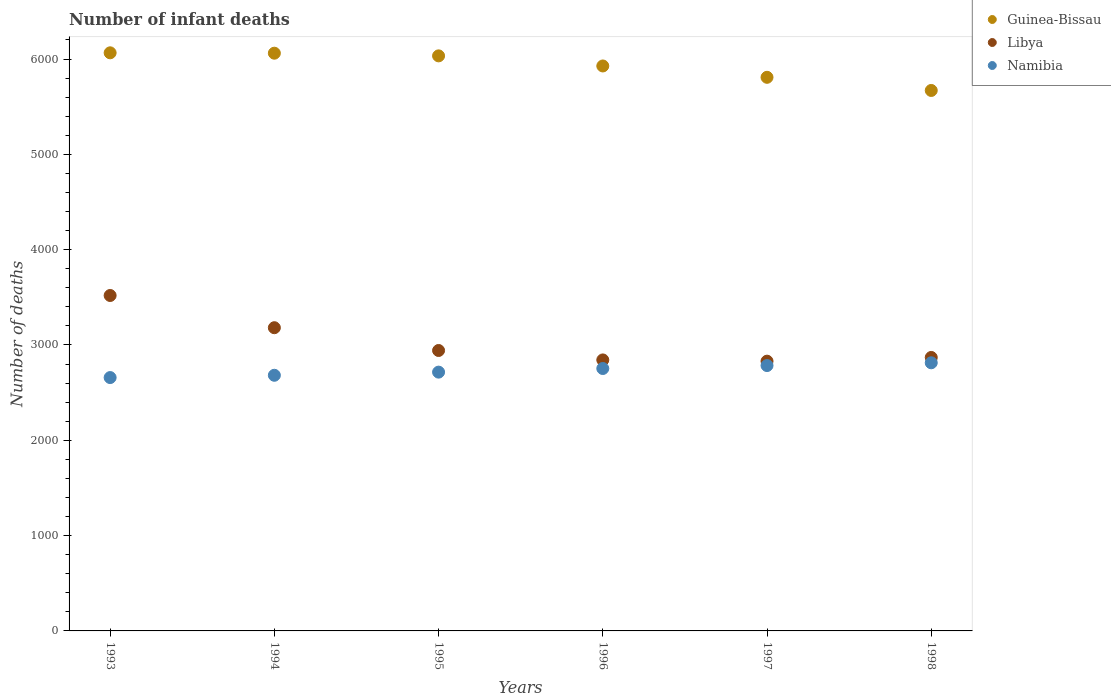How many different coloured dotlines are there?
Offer a terse response. 3. What is the number of infant deaths in Libya in 1994?
Provide a short and direct response. 3181. Across all years, what is the maximum number of infant deaths in Libya?
Your answer should be compact. 3519. Across all years, what is the minimum number of infant deaths in Guinea-Bissau?
Keep it short and to the point. 5670. In which year was the number of infant deaths in Libya maximum?
Your answer should be very brief. 1993. In which year was the number of infant deaths in Guinea-Bissau minimum?
Offer a terse response. 1998. What is the total number of infant deaths in Guinea-Bissau in the graph?
Give a very brief answer. 3.56e+04. What is the difference between the number of infant deaths in Libya in 1997 and that in 1998?
Provide a succinct answer. -39. What is the difference between the number of infant deaths in Libya in 1993 and the number of infant deaths in Namibia in 1998?
Keep it short and to the point. 706. What is the average number of infant deaths in Namibia per year?
Give a very brief answer. 2734.17. In the year 1997, what is the difference between the number of infant deaths in Guinea-Bissau and number of infant deaths in Libya?
Your answer should be compact. 2978. What is the ratio of the number of infant deaths in Guinea-Bissau in 1994 to that in 1996?
Provide a succinct answer. 1.02. Is the number of infant deaths in Libya in 1994 less than that in 1995?
Provide a short and direct response. No. Is the difference between the number of infant deaths in Guinea-Bissau in 1993 and 1997 greater than the difference between the number of infant deaths in Libya in 1993 and 1997?
Provide a short and direct response. No. What is the difference between the highest and the second highest number of infant deaths in Namibia?
Provide a succinct answer. 29. What is the difference between the highest and the lowest number of infant deaths in Namibia?
Ensure brevity in your answer.  155. Is the number of infant deaths in Namibia strictly less than the number of infant deaths in Libya over the years?
Make the answer very short. Yes. How many years are there in the graph?
Your response must be concise. 6. What is the difference between two consecutive major ticks on the Y-axis?
Provide a short and direct response. 1000. Where does the legend appear in the graph?
Your answer should be very brief. Top right. What is the title of the graph?
Offer a terse response. Number of infant deaths. Does "Thailand" appear as one of the legend labels in the graph?
Offer a very short reply. No. What is the label or title of the Y-axis?
Your answer should be very brief. Number of deaths. What is the Number of deaths of Guinea-Bissau in 1993?
Provide a short and direct response. 6065. What is the Number of deaths of Libya in 1993?
Ensure brevity in your answer.  3519. What is the Number of deaths in Namibia in 1993?
Offer a very short reply. 2658. What is the Number of deaths of Guinea-Bissau in 1994?
Keep it short and to the point. 6061. What is the Number of deaths in Libya in 1994?
Offer a very short reply. 3181. What is the Number of deaths in Namibia in 1994?
Provide a short and direct response. 2682. What is the Number of deaths of Guinea-Bissau in 1995?
Your answer should be very brief. 6033. What is the Number of deaths of Libya in 1995?
Make the answer very short. 2942. What is the Number of deaths of Namibia in 1995?
Offer a very short reply. 2715. What is the Number of deaths in Guinea-Bissau in 1996?
Keep it short and to the point. 5927. What is the Number of deaths in Libya in 1996?
Give a very brief answer. 2843. What is the Number of deaths in Namibia in 1996?
Keep it short and to the point. 2753. What is the Number of deaths of Guinea-Bissau in 1997?
Provide a short and direct response. 5808. What is the Number of deaths in Libya in 1997?
Provide a succinct answer. 2830. What is the Number of deaths of Namibia in 1997?
Make the answer very short. 2784. What is the Number of deaths of Guinea-Bissau in 1998?
Provide a short and direct response. 5670. What is the Number of deaths of Libya in 1998?
Offer a very short reply. 2869. What is the Number of deaths in Namibia in 1998?
Give a very brief answer. 2813. Across all years, what is the maximum Number of deaths of Guinea-Bissau?
Offer a terse response. 6065. Across all years, what is the maximum Number of deaths of Libya?
Your answer should be compact. 3519. Across all years, what is the maximum Number of deaths in Namibia?
Make the answer very short. 2813. Across all years, what is the minimum Number of deaths of Guinea-Bissau?
Give a very brief answer. 5670. Across all years, what is the minimum Number of deaths in Libya?
Provide a short and direct response. 2830. Across all years, what is the minimum Number of deaths of Namibia?
Your answer should be very brief. 2658. What is the total Number of deaths in Guinea-Bissau in the graph?
Offer a terse response. 3.56e+04. What is the total Number of deaths in Libya in the graph?
Your response must be concise. 1.82e+04. What is the total Number of deaths of Namibia in the graph?
Provide a succinct answer. 1.64e+04. What is the difference between the Number of deaths in Guinea-Bissau in 1993 and that in 1994?
Provide a short and direct response. 4. What is the difference between the Number of deaths of Libya in 1993 and that in 1994?
Give a very brief answer. 338. What is the difference between the Number of deaths in Libya in 1993 and that in 1995?
Ensure brevity in your answer.  577. What is the difference between the Number of deaths of Namibia in 1993 and that in 1995?
Your response must be concise. -57. What is the difference between the Number of deaths of Guinea-Bissau in 1993 and that in 1996?
Give a very brief answer. 138. What is the difference between the Number of deaths in Libya in 1993 and that in 1996?
Your response must be concise. 676. What is the difference between the Number of deaths of Namibia in 1993 and that in 1996?
Your answer should be compact. -95. What is the difference between the Number of deaths in Guinea-Bissau in 1993 and that in 1997?
Your answer should be very brief. 257. What is the difference between the Number of deaths of Libya in 1993 and that in 1997?
Give a very brief answer. 689. What is the difference between the Number of deaths of Namibia in 1993 and that in 1997?
Provide a succinct answer. -126. What is the difference between the Number of deaths in Guinea-Bissau in 1993 and that in 1998?
Offer a terse response. 395. What is the difference between the Number of deaths in Libya in 1993 and that in 1998?
Offer a very short reply. 650. What is the difference between the Number of deaths in Namibia in 1993 and that in 1998?
Keep it short and to the point. -155. What is the difference between the Number of deaths of Libya in 1994 and that in 1995?
Ensure brevity in your answer.  239. What is the difference between the Number of deaths in Namibia in 1994 and that in 1995?
Your answer should be very brief. -33. What is the difference between the Number of deaths of Guinea-Bissau in 1994 and that in 1996?
Your answer should be very brief. 134. What is the difference between the Number of deaths of Libya in 1994 and that in 1996?
Keep it short and to the point. 338. What is the difference between the Number of deaths of Namibia in 1994 and that in 1996?
Provide a short and direct response. -71. What is the difference between the Number of deaths of Guinea-Bissau in 1994 and that in 1997?
Your answer should be very brief. 253. What is the difference between the Number of deaths of Libya in 1994 and that in 1997?
Your answer should be compact. 351. What is the difference between the Number of deaths in Namibia in 1994 and that in 1997?
Provide a short and direct response. -102. What is the difference between the Number of deaths in Guinea-Bissau in 1994 and that in 1998?
Offer a very short reply. 391. What is the difference between the Number of deaths of Libya in 1994 and that in 1998?
Give a very brief answer. 312. What is the difference between the Number of deaths of Namibia in 1994 and that in 1998?
Keep it short and to the point. -131. What is the difference between the Number of deaths in Guinea-Bissau in 1995 and that in 1996?
Ensure brevity in your answer.  106. What is the difference between the Number of deaths in Namibia in 1995 and that in 1996?
Keep it short and to the point. -38. What is the difference between the Number of deaths of Guinea-Bissau in 1995 and that in 1997?
Offer a very short reply. 225. What is the difference between the Number of deaths of Libya in 1995 and that in 1997?
Provide a succinct answer. 112. What is the difference between the Number of deaths in Namibia in 1995 and that in 1997?
Your response must be concise. -69. What is the difference between the Number of deaths in Guinea-Bissau in 1995 and that in 1998?
Make the answer very short. 363. What is the difference between the Number of deaths of Namibia in 1995 and that in 1998?
Make the answer very short. -98. What is the difference between the Number of deaths in Guinea-Bissau in 1996 and that in 1997?
Ensure brevity in your answer.  119. What is the difference between the Number of deaths of Namibia in 1996 and that in 1997?
Keep it short and to the point. -31. What is the difference between the Number of deaths in Guinea-Bissau in 1996 and that in 1998?
Provide a short and direct response. 257. What is the difference between the Number of deaths in Namibia in 1996 and that in 1998?
Provide a short and direct response. -60. What is the difference between the Number of deaths of Guinea-Bissau in 1997 and that in 1998?
Give a very brief answer. 138. What is the difference between the Number of deaths in Libya in 1997 and that in 1998?
Ensure brevity in your answer.  -39. What is the difference between the Number of deaths of Guinea-Bissau in 1993 and the Number of deaths of Libya in 1994?
Ensure brevity in your answer.  2884. What is the difference between the Number of deaths of Guinea-Bissau in 1993 and the Number of deaths of Namibia in 1994?
Your response must be concise. 3383. What is the difference between the Number of deaths of Libya in 1993 and the Number of deaths of Namibia in 1994?
Your answer should be compact. 837. What is the difference between the Number of deaths of Guinea-Bissau in 1993 and the Number of deaths of Libya in 1995?
Make the answer very short. 3123. What is the difference between the Number of deaths in Guinea-Bissau in 1993 and the Number of deaths in Namibia in 1995?
Provide a short and direct response. 3350. What is the difference between the Number of deaths of Libya in 1993 and the Number of deaths of Namibia in 1995?
Your answer should be compact. 804. What is the difference between the Number of deaths of Guinea-Bissau in 1993 and the Number of deaths of Libya in 1996?
Offer a very short reply. 3222. What is the difference between the Number of deaths in Guinea-Bissau in 1993 and the Number of deaths in Namibia in 1996?
Offer a terse response. 3312. What is the difference between the Number of deaths of Libya in 1993 and the Number of deaths of Namibia in 1996?
Give a very brief answer. 766. What is the difference between the Number of deaths in Guinea-Bissau in 1993 and the Number of deaths in Libya in 1997?
Your response must be concise. 3235. What is the difference between the Number of deaths of Guinea-Bissau in 1993 and the Number of deaths of Namibia in 1997?
Ensure brevity in your answer.  3281. What is the difference between the Number of deaths of Libya in 1993 and the Number of deaths of Namibia in 1997?
Provide a succinct answer. 735. What is the difference between the Number of deaths of Guinea-Bissau in 1993 and the Number of deaths of Libya in 1998?
Provide a succinct answer. 3196. What is the difference between the Number of deaths in Guinea-Bissau in 1993 and the Number of deaths in Namibia in 1998?
Offer a terse response. 3252. What is the difference between the Number of deaths of Libya in 1993 and the Number of deaths of Namibia in 1998?
Give a very brief answer. 706. What is the difference between the Number of deaths in Guinea-Bissau in 1994 and the Number of deaths in Libya in 1995?
Your response must be concise. 3119. What is the difference between the Number of deaths of Guinea-Bissau in 1994 and the Number of deaths of Namibia in 1995?
Provide a short and direct response. 3346. What is the difference between the Number of deaths of Libya in 1994 and the Number of deaths of Namibia in 1995?
Offer a very short reply. 466. What is the difference between the Number of deaths in Guinea-Bissau in 1994 and the Number of deaths in Libya in 1996?
Make the answer very short. 3218. What is the difference between the Number of deaths in Guinea-Bissau in 1994 and the Number of deaths in Namibia in 1996?
Your answer should be compact. 3308. What is the difference between the Number of deaths of Libya in 1994 and the Number of deaths of Namibia in 1996?
Give a very brief answer. 428. What is the difference between the Number of deaths in Guinea-Bissau in 1994 and the Number of deaths in Libya in 1997?
Your answer should be very brief. 3231. What is the difference between the Number of deaths of Guinea-Bissau in 1994 and the Number of deaths of Namibia in 1997?
Provide a short and direct response. 3277. What is the difference between the Number of deaths of Libya in 1994 and the Number of deaths of Namibia in 1997?
Offer a terse response. 397. What is the difference between the Number of deaths in Guinea-Bissau in 1994 and the Number of deaths in Libya in 1998?
Give a very brief answer. 3192. What is the difference between the Number of deaths in Guinea-Bissau in 1994 and the Number of deaths in Namibia in 1998?
Your response must be concise. 3248. What is the difference between the Number of deaths in Libya in 1994 and the Number of deaths in Namibia in 1998?
Make the answer very short. 368. What is the difference between the Number of deaths of Guinea-Bissau in 1995 and the Number of deaths of Libya in 1996?
Ensure brevity in your answer.  3190. What is the difference between the Number of deaths of Guinea-Bissau in 1995 and the Number of deaths of Namibia in 1996?
Your response must be concise. 3280. What is the difference between the Number of deaths of Libya in 1995 and the Number of deaths of Namibia in 1996?
Keep it short and to the point. 189. What is the difference between the Number of deaths in Guinea-Bissau in 1995 and the Number of deaths in Libya in 1997?
Make the answer very short. 3203. What is the difference between the Number of deaths in Guinea-Bissau in 1995 and the Number of deaths in Namibia in 1997?
Ensure brevity in your answer.  3249. What is the difference between the Number of deaths of Libya in 1995 and the Number of deaths of Namibia in 1997?
Your response must be concise. 158. What is the difference between the Number of deaths of Guinea-Bissau in 1995 and the Number of deaths of Libya in 1998?
Provide a succinct answer. 3164. What is the difference between the Number of deaths of Guinea-Bissau in 1995 and the Number of deaths of Namibia in 1998?
Your response must be concise. 3220. What is the difference between the Number of deaths of Libya in 1995 and the Number of deaths of Namibia in 1998?
Provide a succinct answer. 129. What is the difference between the Number of deaths in Guinea-Bissau in 1996 and the Number of deaths in Libya in 1997?
Provide a short and direct response. 3097. What is the difference between the Number of deaths in Guinea-Bissau in 1996 and the Number of deaths in Namibia in 1997?
Your answer should be compact. 3143. What is the difference between the Number of deaths of Libya in 1996 and the Number of deaths of Namibia in 1997?
Your answer should be compact. 59. What is the difference between the Number of deaths in Guinea-Bissau in 1996 and the Number of deaths in Libya in 1998?
Your answer should be very brief. 3058. What is the difference between the Number of deaths of Guinea-Bissau in 1996 and the Number of deaths of Namibia in 1998?
Offer a terse response. 3114. What is the difference between the Number of deaths of Guinea-Bissau in 1997 and the Number of deaths of Libya in 1998?
Your answer should be compact. 2939. What is the difference between the Number of deaths of Guinea-Bissau in 1997 and the Number of deaths of Namibia in 1998?
Make the answer very short. 2995. What is the difference between the Number of deaths of Libya in 1997 and the Number of deaths of Namibia in 1998?
Give a very brief answer. 17. What is the average Number of deaths of Guinea-Bissau per year?
Make the answer very short. 5927.33. What is the average Number of deaths in Libya per year?
Provide a short and direct response. 3030.67. What is the average Number of deaths in Namibia per year?
Your answer should be compact. 2734.17. In the year 1993, what is the difference between the Number of deaths in Guinea-Bissau and Number of deaths in Libya?
Ensure brevity in your answer.  2546. In the year 1993, what is the difference between the Number of deaths in Guinea-Bissau and Number of deaths in Namibia?
Make the answer very short. 3407. In the year 1993, what is the difference between the Number of deaths in Libya and Number of deaths in Namibia?
Your answer should be very brief. 861. In the year 1994, what is the difference between the Number of deaths in Guinea-Bissau and Number of deaths in Libya?
Your answer should be very brief. 2880. In the year 1994, what is the difference between the Number of deaths of Guinea-Bissau and Number of deaths of Namibia?
Make the answer very short. 3379. In the year 1994, what is the difference between the Number of deaths in Libya and Number of deaths in Namibia?
Your answer should be very brief. 499. In the year 1995, what is the difference between the Number of deaths of Guinea-Bissau and Number of deaths of Libya?
Offer a terse response. 3091. In the year 1995, what is the difference between the Number of deaths in Guinea-Bissau and Number of deaths in Namibia?
Give a very brief answer. 3318. In the year 1995, what is the difference between the Number of deaths of Libya and Number of deaths of Namibia?
Make the answer very short. 227. In the year 1996, what is the difference between the Number of deaths of Guinea-Bissau and Number of deaths of Libya?
Your answer should be compact. 3084. In the year 1996, what is the difference between the Number of deaths in Guinea-Bissau and Number of deaths in Namibia?
Offer a very short reply. 3174. In the year 1996, what is the difference between the Number of deaths in Libya and Number of deaths in Namibia?
Keep it short and to the point. 90. In the year 1997, what is the difference between the Number of deaths of Guinea-Bissau and Number of deaths of Libya?
Make the answer very short. 2978. In the year 1997, what is the difference between the Number of deaths in Guinea-Bissau and Number of deaths in Namibia?
Your answer should be compact. 3024. In the year 1998, what is the difference between the Number of deaths of Guinea-Bissau and Number of deaths of Libya?
Your answer should be very brief. 2801. In the year 1998, what is the difference between the Number of deaths in Guinea-Bissau and Number of deaths in Namibia?
Offer a terse response. 2857. What is the ratio of the Number of deaths in Guinea-Bissau in 1993 to that in 1994?
Offer a very short reply. 1. What is the ratio of the Number of deaths in Libya in 1993 to that in 1994?
Ensure brevity in your answer.  1.11. What is the ratio of the Number of deaths of Namibia in 1993 to that in 1994?
Your response must be concise. 0.99. What is the ratio of the Number of deaths of Libya in 1993 to that in 1995?
Your answer should be compact. 1.2. What is the ratio of the Number of deaths in Guinea-Bissau in 1993 to that in 1996?
Provide a succinct answer. 1.02. What is the ratio of the Number of deaths of Libya in 1993 to that in 1996?
Provide a succinct answer. 1.24. What is the ratio of the Number of deaths of Namibia in 1993 to that in 1996?
Offer a terse response. 0.97. What is the ratio of the Number of deaths in Guinea-Bissau in 1993 to that in 1997?
Your answer should be compact. 1.04. What is the ratio of the Number of deaths in Libya in 1993 to that in 1997?
Your answer should be very brief. 1.24. What is the ratio of the Number of deaths in Namibia in 1993 to that in 1997?
Provide a succinct answer. 0.95. What is the ratio of the Number of deaths of Guinea-Bissau in 1993 to that in 1998?
Provide a succinct answer. 1.07. What is the ratio of the Number of deaths in Libya in 1993 to that in 1998?
Offer a very short reply. 1.23. What is the ratio of the Number of deaths of Namibia in 1993 to that in 1998?
Your answer should be compact. 0.94. What is the ratio of the Number of deaths in Libya in 1994 to that in 1995?
Offer a terse response. 1.08. What is the ratio of the Number of deaths in Namibia in 1994 to that in 1995?
Keep it short and to the point. 0.99. What is the ratio of the Number of deaths of Guinea-Bissau in 1994 to that in 1996?
Provide a short and direct response. 1.02. What is the ratio of the Number of deaths of Libya in 1994 to that in 1996?
Ensure brevity in your answer.  1.12. What is the ratio of the Number of deaths of Namibia in 1994 to that in 1996?
Provide a succinct answer. 0.97. What is the ratio of the Number of deaths in Guinea-Bissau in 1994 to that in 1997?
Your answer should be compact. 1.04. What is the ratio of the Number of deaths in Libya in 1994 to that in 1997?
Keep it short and to the point. 1.12. What is the ratio of the Number of deaths of Namibia in 1994 to that in 1997?
Keep it short and to the point. 0.96. What is the ratio of the Number of deaths of Guinea-Bissau in 1994 to that in 1998?
Offer a terse response. 1.07. What is the ratio of the Number of deaths in Libya in 1994 to that in 1998?
Provide a succinct answer. 1.11. What is the ratio of the Number of deaths of Namibia in 1994 to that in 1998?
Keep it short and to the point. 0.95. What is the ratio of the Number of deaths in Guinea-Bissau in 1995 to that in 1996?
Provide a succinct answer. 1.02. What is the ratio of the Number of deaths of Libya in 1995 to that in 1996?
Your response must be concise. 1.03. What is the ratio of the Number of deaths of Namibia in 1995 to that in 1996?
Ensure brevity in your answer.  0.99. What is the ratio of the Number of deaths of Guinea-Bissau in 1995 to that in 1997?
Your answer should be compact. 1.04. What is the ratio of the Number of deaths in Libya in 1995 to that in 1997?
Keep it short and to the point. 1.04. What is the ratio of the Number of deaths of Namibia in 1995 to that in 1997?
Your response must be concise. 0.98. What is the ratio of the Number of deaths of Guinea-Bissau in 1995 to that in 1998?
Provide a succinct answer. 1.06. What is the ratio of the Number of deaths in Libya in 1995 to that in 1998?
Your response must be concise. 1.03. What is the ratio of the Number of deaths of Namibia in 1995 to that in 1998?
Offer a terse response. 0.97. What is the ratio of the Number of deaths of Guinea-Bissau in 1996 to that in 1997?
Keep it short and to the point. 1.02. What is the ratio of the Number of deaths in Libya in 1996 to that in 1997?
Keep it short and to the point. 1. What is the ratio of the Number of deaths of Namibia in 1996 to that in 1997?
Make the answer very short. 0.99. What is the ratio of the Number of deaths in Guinea-Bissau in 1996 to that in 1998?
Ensure brevity in your answer.  1.05. What is the ratio of the Number of deaths in Libya in 1996 to that in 1998?
Your response must be concise. 0.99. What is the ratio of the Number of deaths in Namibia in 1996 to that in 1998?
Ensure brevity in your answer.  0.98. What is the ratio of the Number of deaths of Guinea-Bissau in 1997 to that in 1998?
Give a very brief answer. 1.02. What is the ratio of the Number of deaths in Libya in 1997 to that in 1998?
Offer a terse response. 0.99. What is the ratio of the Number of deaths of Namibia in 1997 to that in 1998?
Your response must be concise. 0.99. What is the difference between the highest and the second highest Number of deaths in Libya?
Your answer should be compact. 338. What is the difference between the highest and the lowest Number of deaths of Guinea-Bissau?
Make the answer very short. 395. What is the difference between the highest and the lowest Number of deaths in Libya?
Make the answer very short. 689. What is the difference between the highest and the lowest Number of deaths in Namibia?
Ensure brevity in your answer.  155. 